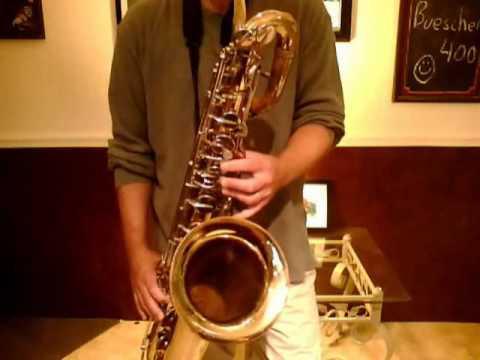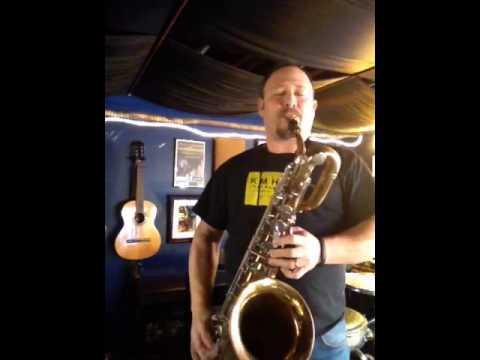The first image is the image on the left, the second image is the image on the right. For the images shown, is this caption "A man is holding the saxophone in the image on the right." true? Answer yes or no. Yes. The first image is the image on the left, the second image is the image on the right. Given the left and right images, does the statement "A man in a short-sleeved black shirt is holding a saxophone." hold true? Answer yes or no. Yes. 